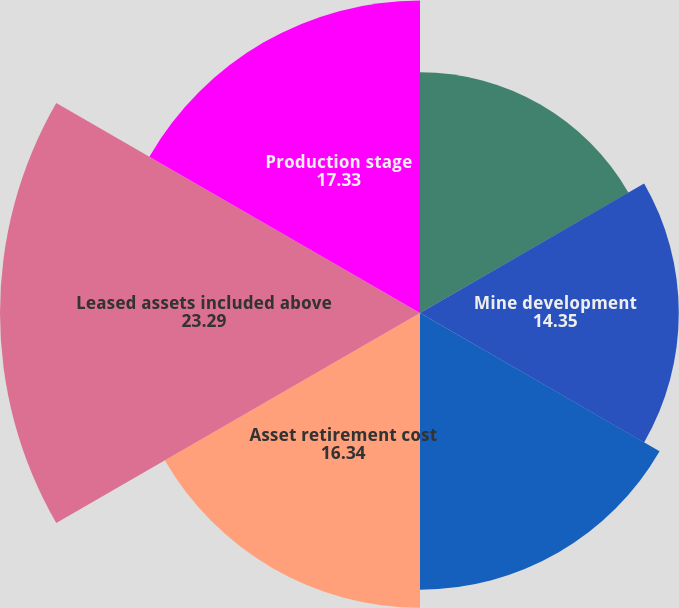<chart> <loc_0><loc_0><loc_500><loc_500><pie_chart><fcel>Facilities and equipment<fcel>Mine development<fcel>Mineral interests<fcel>Asset retirement cost<fcel>Leased assets included above<fcel>Production stage<nl><fcel>13.35%<fcel>14.35%<fcel>15.34%<fcel>16.34%<fcel>23.29%<fcel>17.33%<nl></chart> 